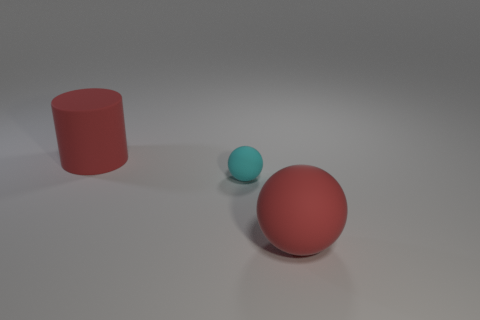There is a cyan object; does it have the same shape as the red rubber thing behind the tiny cyan rubber object?
Offer a terse response. No. What number of other things are there of the same material as the large red ball
Your answer should be very brief. 2. Are there any cyan objects in front of the red sphere?
Your answer should be compact. No. Is the size of the red matte cylinder the same as the red object to the right of the large red rubber cylinder?
Provide a succinct answer. Yes. The large rubber thing behind the large red rubber thing that is in front of the cyan sphere is what color?
Your answer should be very brief. Red. Is the cylinder the same size as the cyan thing?
Provide a succinct answer. No. What is the color of the matte object that is both behind the large rubber ball and in front of the red rubber cylinder?
Provide a succinct answer. Cyan. What size is the matte cylinder?
Provide a short and direct response. Large. There is a big object in front of the big red cylinder; is it the same color as the tiny ball?
Give a very brief answer. No. Are there more big red cylinders behind the big ball than cyan matte balls in front of the cyan rubber thing?
Keep it short and to the point. Yes. 